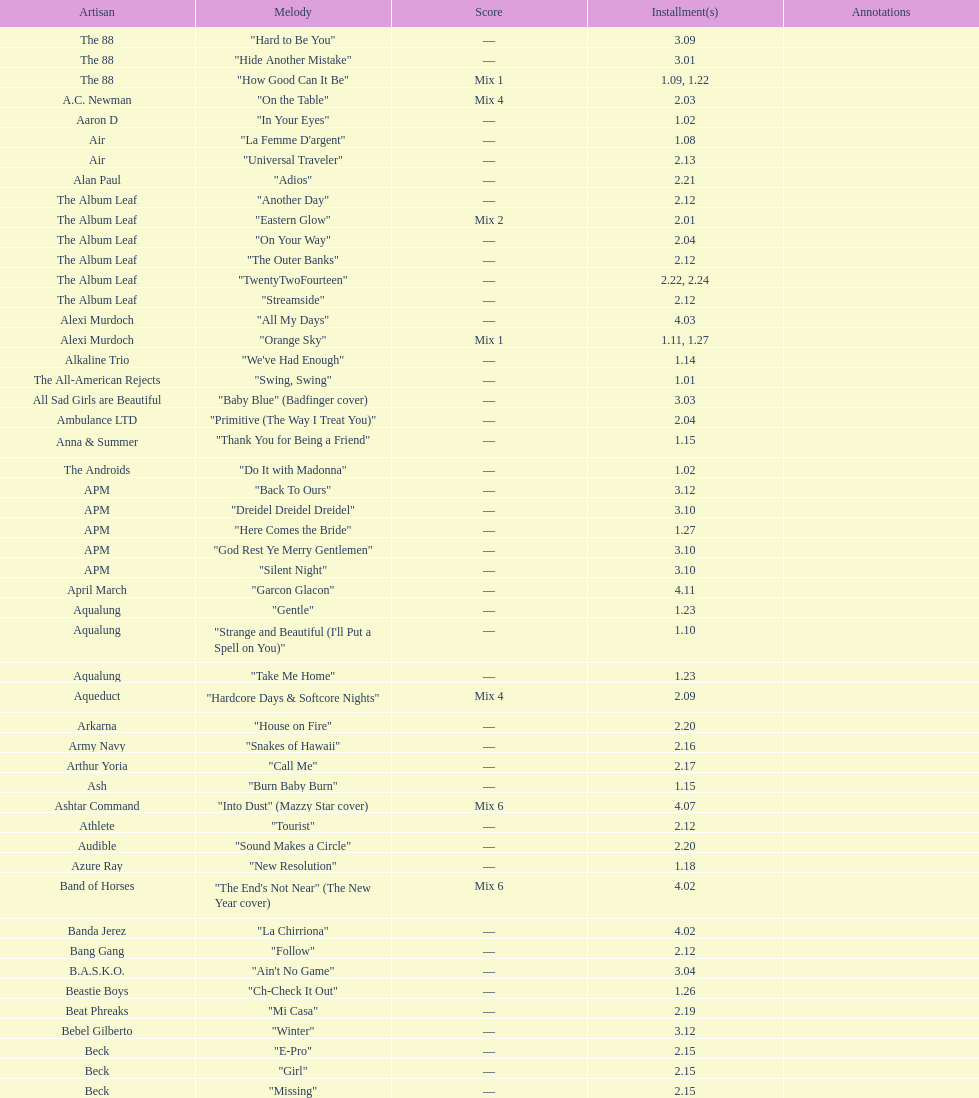How many consecutive songs were by the album leaf? 6. 